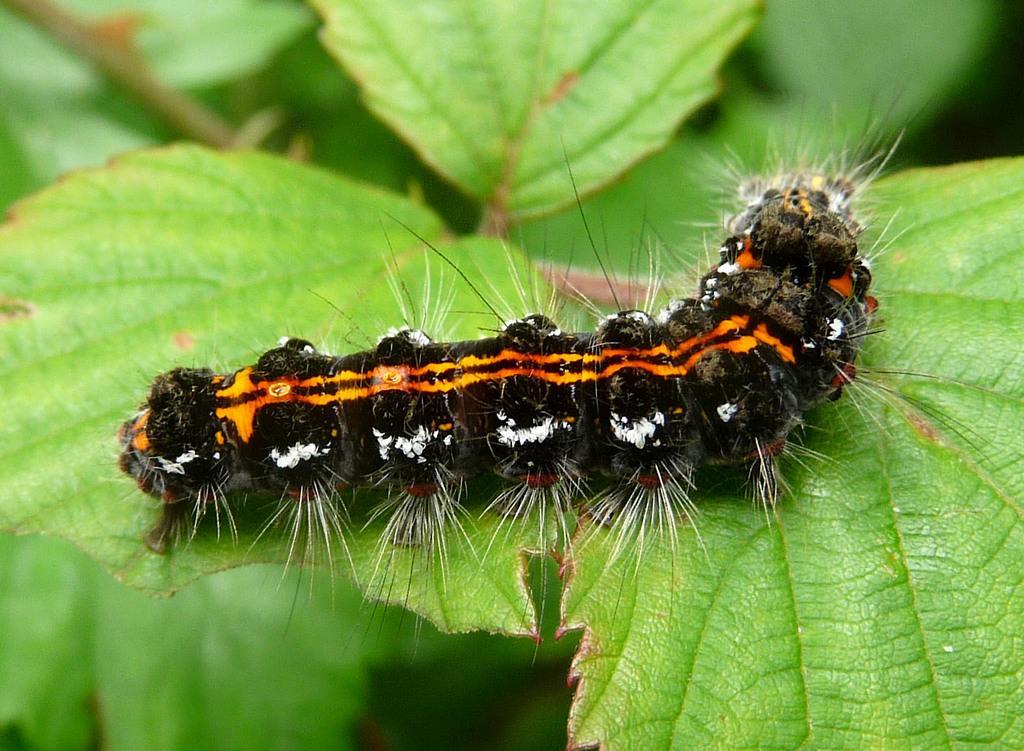Describe this image in one or two sentences. In the picture I can see the green leaves and there is a caterpillar on the green leaf. 